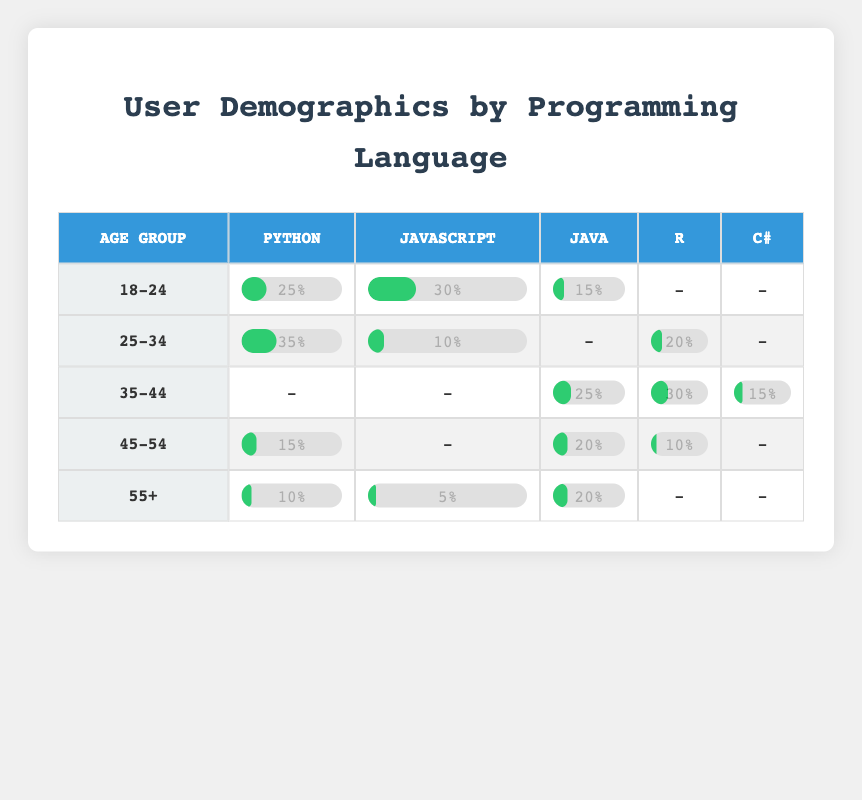What is the percentage of users aged 25-34 who prefer Python? From the table, under the age group 25-34, the percentage listed for Python is 35%. Therefore, the answer is directly taken from this cell of the table.
Answer: 35% Which programming language is most preferred by users aged 18-24? Looking at the row for the age group 18-24, we can see the percentages for Python (25%), JavaScript (30%), and Java (15%). The highest percentage is for JavaScript (30%).
Answer: JavaScript How many programming languages have a preference percentage of at least 20% among users aged 35-44? For the age group 35-44, we have R (30%), Java (25%), and C# (15%) with percentages of at least 20%. Counting the languages with 20% or higher, we see R and Java meet this criterion. Therefore, there are 2 languages.
Answer: 2 Is there any programming language preferred by users aged 55+ with a percentage higher than 10%? Reviewing the 55+ age group, Python has a percentage of 10%, JavaScript has 5%, and Java has 20%. Since Java has a percentage of 20%, which is higher than 10%, the answer is yes.
Answer: Yes What is the average percentage of users who prefer Java across all age groups? To find the average for Java, we look at the percentages for each age group: 15% (18-24), 20% (45-54), and 25% (35-44). Adding these gives 15 + 20 + 25 = 60%. There are 3 data points, so we divide by 3 to find the average: 60% / 3 = 20%.
Answer: 20% Which age group has the highest preferred percentage for R? In the table, R has the highest percentage in the age group 35-44 with 30%. Thus, the answer is this age group as they dominate the preference for R.
Answer: 35-44 How does the preference for JavaScript compare between users aged 25-34 and those aged 35-44? The preference percentage for JavaScript in the age group 25-34 is 10%, while for 35-44, it is not preferred as the value is represented with a dash (-). Therefore, JavaScript is more preferred by 25-34 individuals starting with 10%.
Answer: 25-34 is preferred What is the difference in percentage between the most and least preferred programming languages for users aged 45-54? In this age group, the percentages are: Java (20%), Python (15%), R (10%). The highest is Java (20%) and the lowest is R (10%). The difference is calculated as 20% - 10% = 10%.
Answer: 10% 